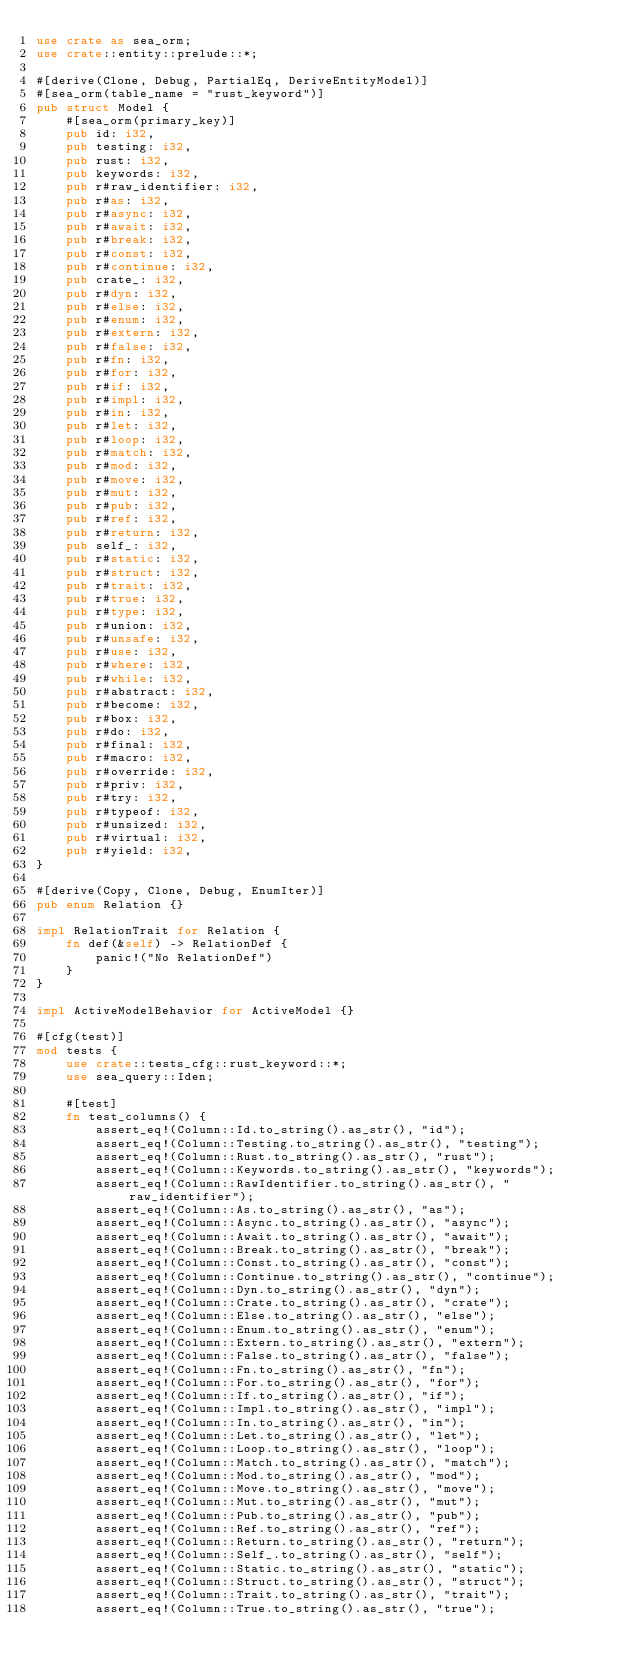Convert code to text. <code><loc_0><loc_0><loc_500><loc_500><_Rust_>use crate as sea_orm;
use crate::entity::prelude::*;

#[derive(Clone, Debug, PartialEq, DeriveEntityModel)]
#[sea_orm(table_name = "rust_keyword")]
pub struct Model {
    #[sea_orm(primary_key)]
    pub id: i32,
    pub testing: i32,
    pub rust: i32,
    pub keywords: i32,
    pub r#raw_identifier: i32,
    pub r#as: i32,
    pub r#async: i32,
    pub r#await: i32,
    pub r#break: i32,
    pub r#const: i32,
    pub r#continue: i32,
    pub crate_: i32,
    pub r#dyn: i32,
    pub r#else: i32,
    pub r#enum: i32,
    pub r#extern: i32,
    pub r#false: i32,
    pub r#fn: i32,
    pub r#for: i32,
    pub r#if: i32,
    pub r#impl: i32,
    pub r#in: i32,
    pub r#let: i32,
    pub r#loop: i32,
    pub r#match: i32,
    pub r#mod: i32,
    pub r#move: i32,
    pub r#mut: i32,
    pub r#pub: i32,
    pub r#ref: i32,
    pub r#return: i32,
    pub self_: i32,
    pub r#static: i32,
    pub r#struct: i32,
    pub r#trait: i32,
    pub r#true: i32,
    pub r#type: i32,
    pub r#union: i32,
    pub r#unsafe: i32,
    pub r#use: i32,
    pub r#where: i32,
    pub r#while: i32,
    pub r#abstract: i32,
    pub r#become: i32,
    pub r#box: i32,
    pub r#do: i32,
    pub r#final: i32,
    pub r#macro: i32,
    pub r#override: i32,
    pub r#priv: i32,
    pub r#try: i32,
    pub r#typeof: i32,
    pub r#unsized: i32,
    pub r#virtual: i32,
    pub r#yield: i32,
}

#[derive(Copy, Clone, Debug, EnumIter)]
pub enum Relation {}

impl RelationTrait for Relation {
    fn def(&self) -> RelationDef {
        panic!("No RelationDef")
    }
}

impl ActiveModelBehavior for ActiveModel {}

#[cfg(test)]
mod tests {
    use crate::tests_cfg::rust_keyword::*;
    use sea_query::Iden;

    #[test]
    fn test_columns() {
        assert_eq!(Column::Id.to_string().as_str(), "id");
        assert_eq!(Column::Testing.to_string().as_str(), "testing");
        assert_eq!(Column::Rust.to_string().as_str(), "rust");
        assert_eq!(Column::Keywords.to_string().as_str(), "keywords");
        assert_eq!(Column::RawIdentifier.to_string().as_str(), "raw_identifier");
        assert_eq!(Column::As.to_string().as_str(), "as");
        assert_eq!(Column::Async.to_string().as_str(), "async");
        assert_eq!(Column::Await.to_string().as_str(), "await");
        assert_eq!(Column::Break.to_string().as_str(), "break");
        assert_eq!(Column::Const.to_string().as_str(), "const");
        assert_eq!(Column::Continue.to_string().as_str(), "continue");
        assert_eq!(Column::Dyn.to_string().as_str(), "dyn");
        assert_eq!(Column::Crate.to_string().as_str(), "crate");
        assert_eq!(Column::Else.to_string().as_str(), "else");
        assert_eq!(Column::Enum.to_string().as_str(), "enum");
        assert_eq!(Column::Extern.to_string().as_str(), "extern");
        assert_eq!(Column::False.to_string().as_str(), "false");
        assert_eq!(Column::Fn.to_string().as_str(), "fn");
        assert_eq!(Column::For.to_string().as_str(), "for");
        assert_eq!(Column::If.to_string().as_str(), "if");
        assert_eq!(Column::Impl.to_string().as_str(), "impl");
        assert_eq!(Column::In.to_string().as_str(), "in");
        assert_eq!(Column::Let.to_string().as_str(), "let");
        assert_eq!(Column::Loop.to_string().as_str(), "loop");
        assert_eq!(Column::Match.to_string().as_str(), "match");
        assert_eq!(Column::Mod.to_string().as_str(), "mod");
        assert_eq!(Column::Move.to_string().as_str(), "move");
        assert_eq!(Column::Mut.to_string().as_str(), "mut");
        assert_eq!(Column::Pub.to_string().as_str(), "pub");
        assert_eq!(Column::Ref.to_string().as_str(), "ref");
        assert_eq!(Column::Return.to_string().as_str(), "return");
        assert_eq!(Column::Self_.to_string().as_str(), "self");
        assert_eq!(Column::Static.to_string().as_str(), "static");
        assert_eq!(Column::Struct.to_string().as_str(), "struct");
        assert_eq!(Column::Trait.to_string().as_str(), "trait");
        assert_eq!(Column::True.to_string().as_str(), "true");</code> 